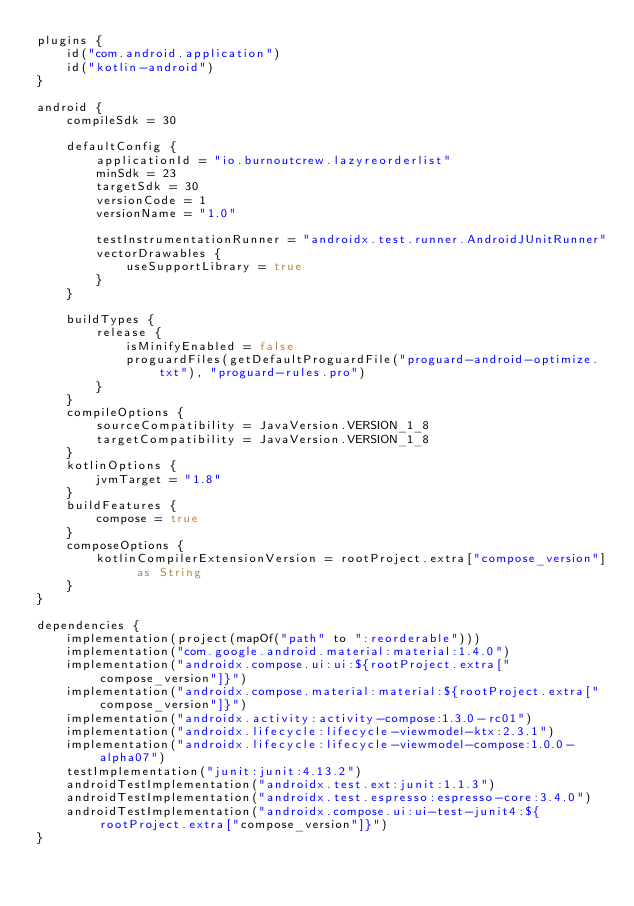Convert code to text. <code><loc_0><loc_0><loc_500><loc_500><_Kotlin_>plugins {
    id("com.android.application")
    id("kotlin-android")
}

android {
    compileSdk = 30

    defaultConfig {
        applicationId = "io.burnoutcrew.lazyreorderlist"
        minSdk = 23
        targetSdk = 30
        versionCode = 1
        versionName = "1.0"

        testInstrumentationRunner = "androidx.test.runner.AndroidJUnitRunner"
        vectorDrawables {
            useSupportLibrary = true
        }
    }

    buildTypes {
        release {
            isMinifyEnabled = false
            proguardFiles(getDefaultProguardFile("proguard-android-optimize.txt"), "proguard-rules.pro")
        }
    }
    compileOptions {
        sourceCompatibility = JavaVersion.VERSION_1_8
        targetCompatibility = JavaVersion.VERSION_1_8
    }
    kotlinOptions {
        jvmTarget = "1.8"
    }
    buildFeatures {
        compose = true
    }
    composeOptions {
        kotlinCompilerExtensionVersion = rootProject.extra["compose_version"] as String
    }
}

dependencies {
    implementation(project(mapOf("path" to ":reorderable")))
    implementation("com.google.android.material:material:1.4.0")
    implementation("androidx.compose.ui:ui:${rootProject.extra["compose_version"]}")
    implementation("androidx.compose.material:material:${rootProject.extra["compose_version"]}")
    implementation("androidx.activity:activity-compose:1.3.0-rc01")
    implementation("androidx.lifecycle:lifecycle-viewmodel-ktx:2.3.1")
    implementation("androidx.lifecycle:lifecycle-viewmodel-compose:1.0.0-alpha07")
    testImplementation("junit:junit:4.13.2")
    androidTestImplementation("androidx.test.ext:junit:1.1.3")
    androidTestImplementation("androidx.test.espresso:espresso-core:3.4.0")
    androidTestImplementation("androidx.compose.ui:ui-test-junit4:${rootProject.extra["compose_version"]}")
}</code> 